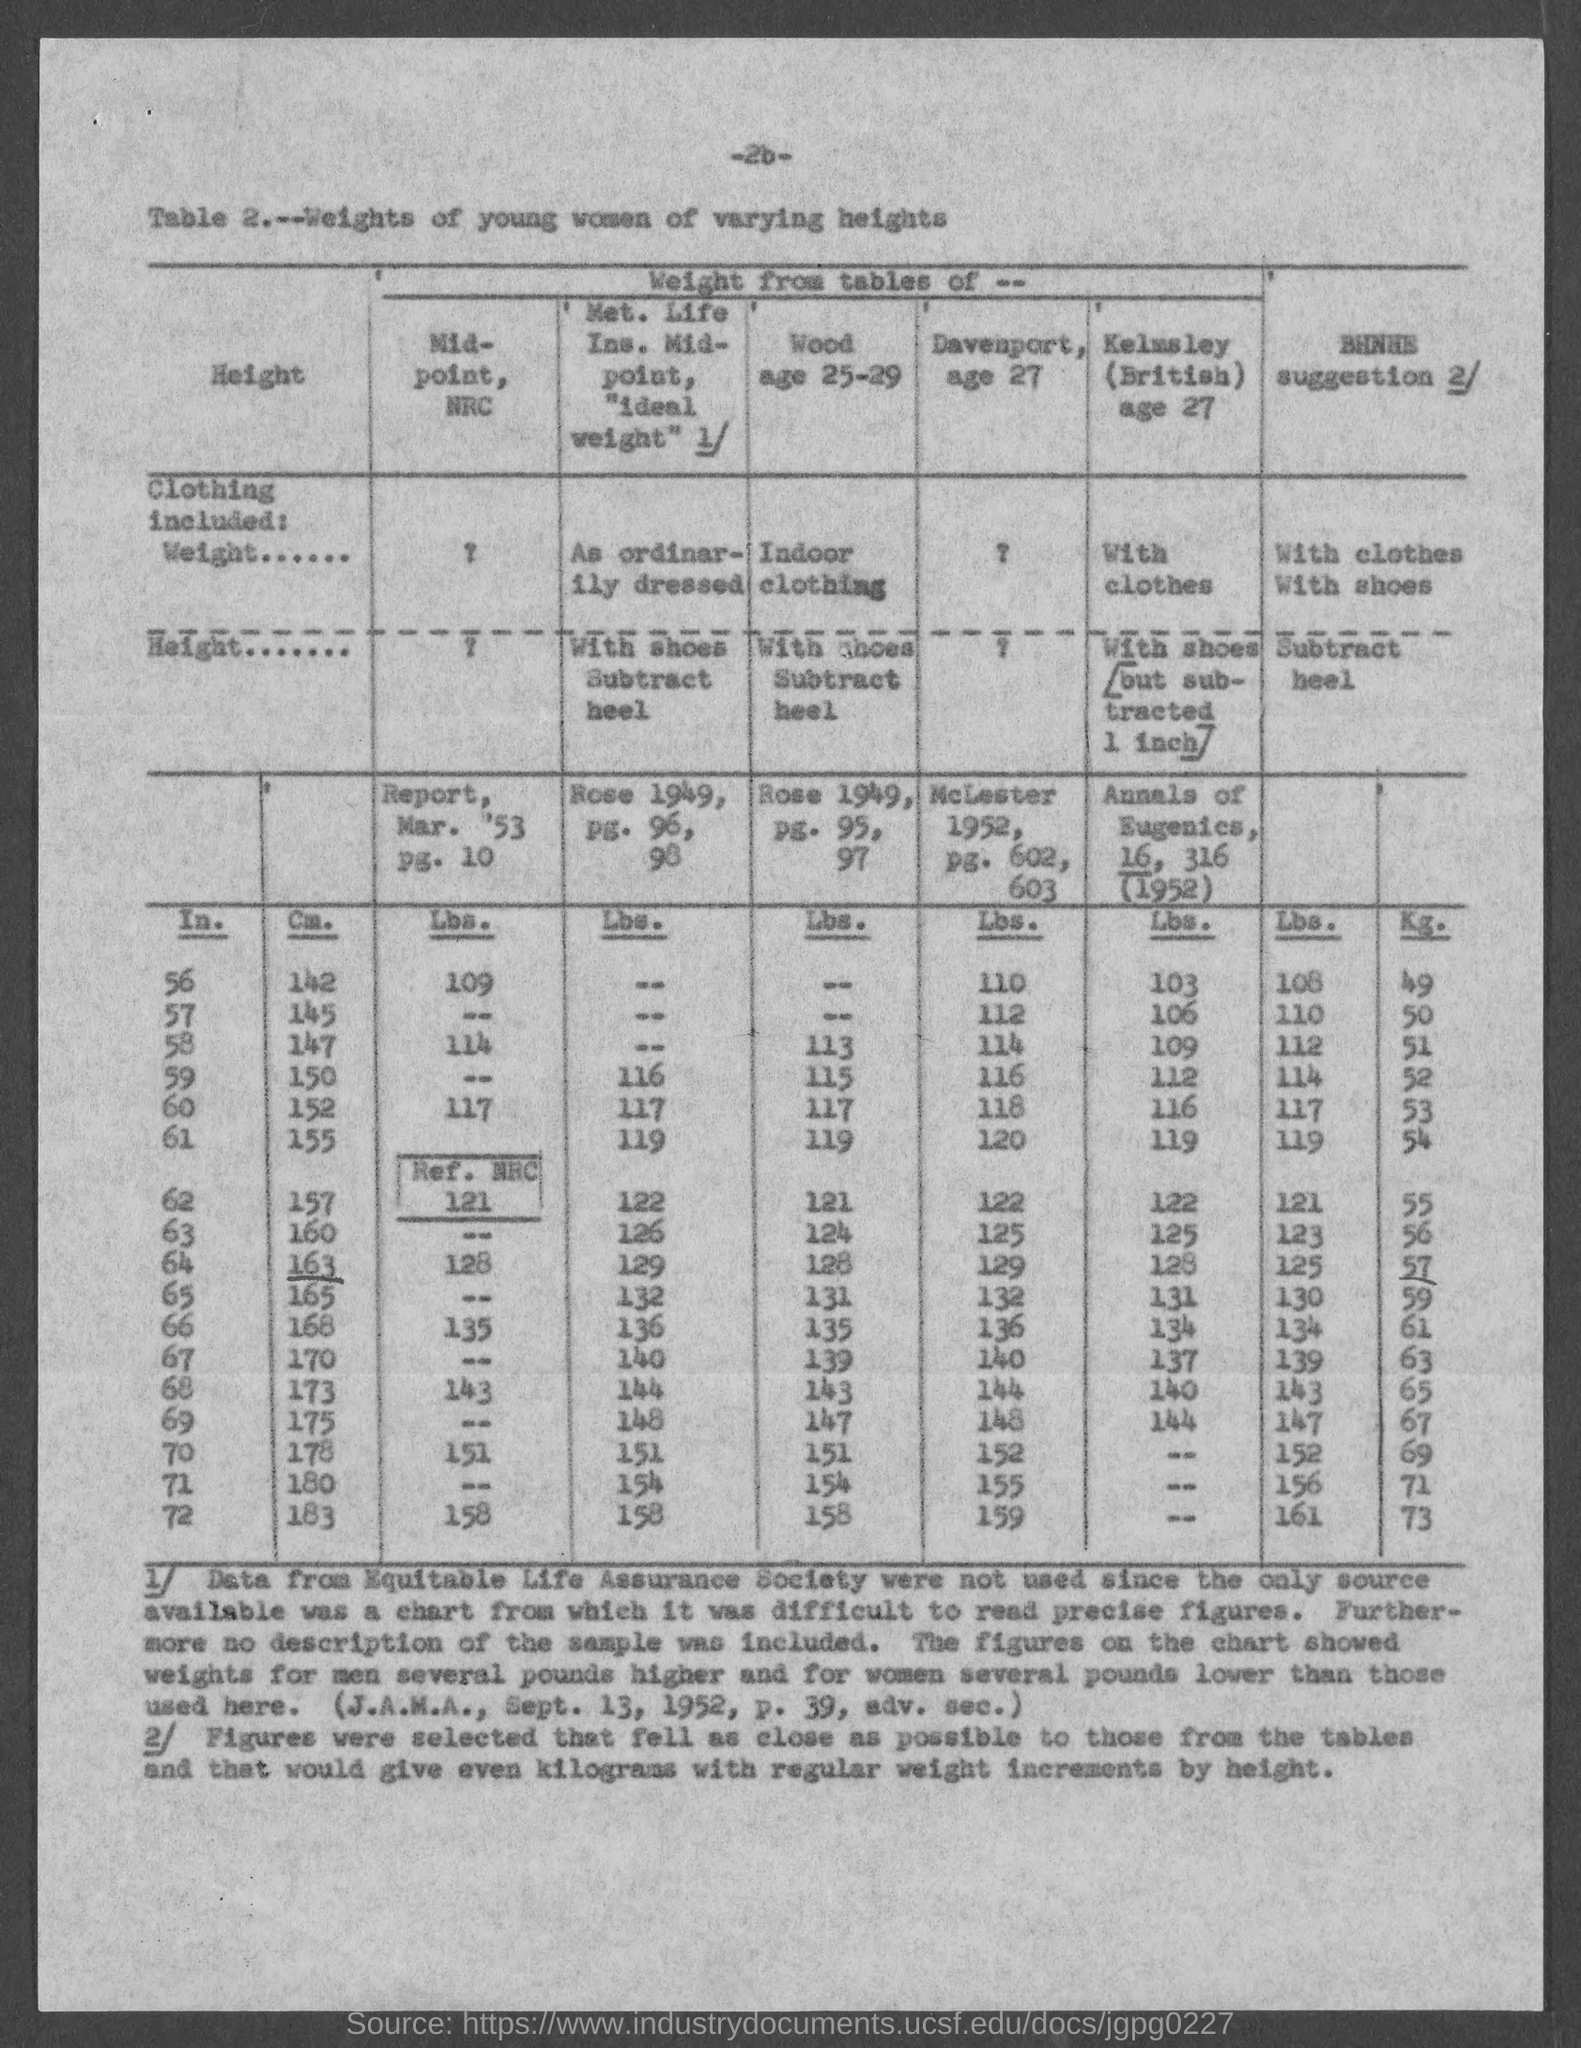Specify some key components in this picture. The title of the table is "Weights of Young Women of Varying Heights. The page number at the top of the page is 26. 